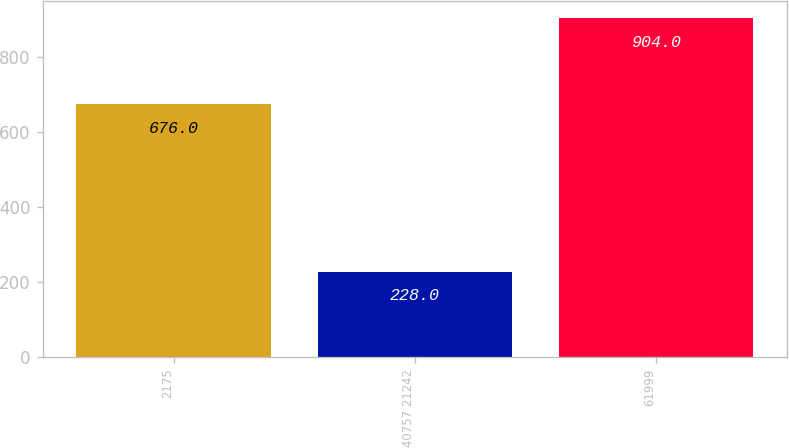Convert chart. <chart><loc_0><loc_0><loc_500><loc_500><bar_chart><fcel>2175<fcel>40757 21242<fcel>61999<nl><fcel>676<fcel>228<fcel>904<nl></chart> 